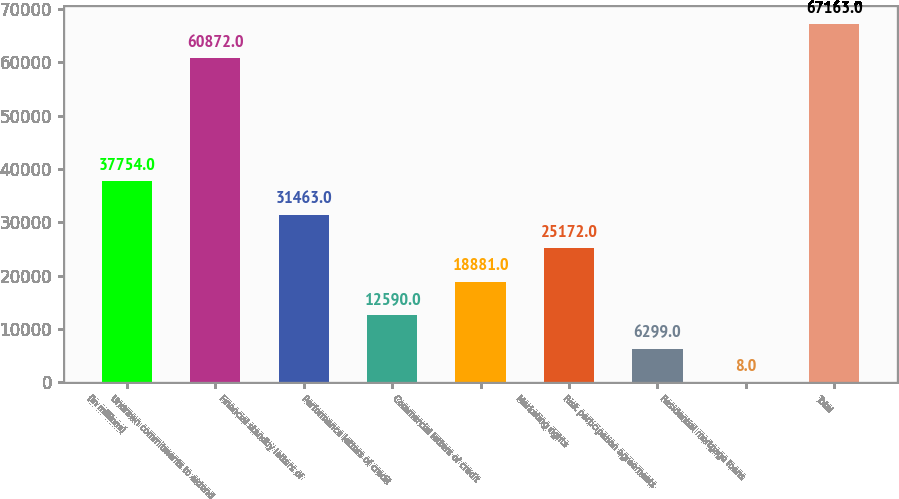<chart> <loc_0><loc_0><loc_500><loc_500><bar_chart><fcel>(in millions)<fcel>Undrawn commitments to extend<fcel>Financial standby letters of<fcel>Performance letters of credit<fcel>Commercial letters of credit<fcel>Marketing rights<fcel>Risk participation agreements<fcel>Residential mortgage loans<fcel>Total<nl><fcel>37754<fcel>60872<fcel>31463<fcel>12590<fcel>18881<fcel>25172<fcel>6299<fcel>8<fcel>67163<nl></chart> 